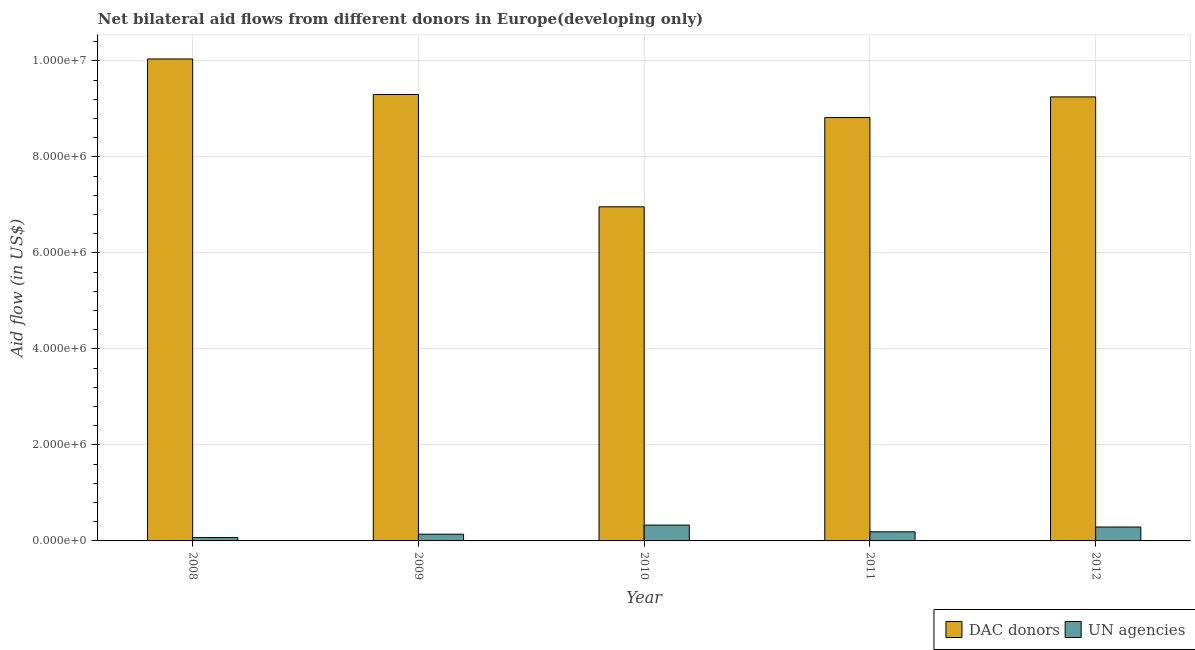Are the number of bars per tick equal to the number of legend labels?
Offer a very short reply. Yes. What is the aid flow from un agencies in 2012?
Ensure brevity in your answer.  2.90e+05. Across all years, what is the maximum aid flow from un agencies?
Make the answer very short. 3.30e+05. Across all years, what is the minimum aid flow from un agencies?
Give a very brief answer. 7.00e+04. In which year was the aid flow from dac donors maximum?
Keep it short and to the point. 2008. In which year was the aid flow from un agencies minimum?
Offer a terse response. 2008. What is the total aid flow from un agencies in the graph?
Your response must be concise. 1.02e+06. What is the difference between the aid flow from un agencies in 2008 and that in 2010?
Your answer should be very brief. -2.60e+05. What is the difference between the aid flow from un agencies in 2010 and the aid flow from dac donors in 2009?
Provide a short and direct response. 1.90e+05. What is the average aid flow from dac donors per year?
Offer a very short reply. 8.87e+06. In the year 2008, what is the difference between the aid flow from un agencies and aid flow from dac donors?
Give a very brief answer. 0. What is the ratio of the aid flow from dac donors in 2010 to that in 2011?
Give a very brief answer. 0.79. What is the difference between the highest and the second highest aid flow from dac donors?
Offer a terse response. 7.40e+05. What is the difference between the highest and the lowest aid flow from dac donors?
Keep it short and to the point. 3.08e+06. In how many years, is the aid flow from un agencies greater than the average aid flow from un agencies taken over all years?
Your answer should be compact. 2. What does the 1st bar from the left in 2011 represents?
Make the answer very short. DAC donors. What does the 1st bar from the right in 2009 represents?
Offer a very short reply. UN agencies. How many years are there in the graph?
Your response must be concise. 5. Are the values on the major ticks of Y-axis written in scientific E-notation?
Keep it short and to the point. Yes. Does the graph contain grids?
Give a very brief answer. Yes. Where does the legend appear in the graph?
Provide a short and direct response. Bottom right. How many legend labels are there?
Keep it short and to the point. 2. How are the legend labels stacked?
Ensure brevity in your answer.  Horizontal. What is the title of the graph?
Offer a terse response. Net bilateral aid flows from different donors in Europe(developing only). What is the label or title of the X-axis?
Your answer should be very brief. Year. What is the label or title of the Y-axis?
Your answer should be very brief. Aid flow (in US$). What is the Aid flow (in US$) of DAC donors in 2008?
Give a very brief answer. 1.00e+07. What is the Aid flow (in US$) of UN agencies in 2008?
Make the answer very short. 7.00e+04. What is the Aid flow (in US$) in DAC donors in 2009?
Offer a terse response. 9.30e+06. What is the Aid flow (in US$) in DAC donors in 2010?
Your response must be concise. 6.96e+06. What is the Aid flow (in US$) in DAC donors in 2011?
Make the answer very short. 8.82e+06. What is the Aid flow (in US$) of DAC donors in 2012?
Offer a terse response. 9.25e+06. Across all years, what is the maximum Aid flow (in US$) of DAC donors?
Your response must be concise. 1.00e+07. Across all years, what is the maximum Aid flow (in US$) of UN agencies?
Your answer should be compact. 3.30e+05. Across all years, what is the minimum Aid flow (in US$) in DAC donors?
Your answer should be compact. 6.96e+06. Across all years, what is the minimum Aid flow (in US$) of UN agencies?
Ensure brevity in your answer.  7.00e+04. What is the total Aid flow (in US$) in DAC donors in the graph?
Provide a succinct answer. 4.44e+07. What is the total Aid flow (in US$) in UN agencies in the graph?
Offer a terse response. 1.02e+06. What is the difference between the Aid flow (in US$) of DAC donors in 2008 and that in 2009?
Give a very brief answer. 7.40e+05. What is the difference between the Aid flow (in US$) in DAC donors in 2008 and that in 2010?
Your answer should be very brief. 3.08e+06. What is the difference between the Aid flow (in US$) in UN agencies in 2008 and that in 2010?
Offer a very short reply. -2.60e+05. What is the difference between the Aid flow (in US$) in DAC donors in 2008 and that in 2011?
Your response must be concise. 1.22e+06. What is the difference between the Aid flow (in US$) in UN agencies in 2008 and that in 2011?
Make the answer very short. -1.20e+05. What is the difference between the Aid flow (in US$) in DAC donors in 2008 and that in 2012?
Make the answer very short. 7.90e+05. What is the difference between the Aid flow (in US$) of DAC donors in 2009 and that in 2010?
Your answer should be compact. 2.34e+06. What is the difference between the Aid flow (in US$) of UN agencies in 2009 and that in 2011?
Make the answer very short. -5.00e+04. What is the difference between the Aid flow (in US$) in UN agencies in 2009 and that in 2012?
Make the answer very short. -1.50e+05. What is the difference between the Aid flow (in US$) in DAC donors in 2010 and that in 2011?
Your answer should be compact. -1.86e+06. What is the difference between the Aid flow (in US$) in DAC donors in 2010 and that in 2012?
Offer a very short reply. -2.29e+06. What is the difference between the Aid flow (in US$) in UN agencies in 2010 and that in 2012?
Provide a short and direct response. 4.00e+04. What is the difference between the Aid flow (in US$) in DAC donors in 2011 and that in 2012?
Provide a short and direct response. -4.30e+05. What is the difference between the Aid flow (in US$) in UN agencies in 2011 and that in 2012?
Ensure brevity in your answer.  -1.00e+05. What is the difference between the Aid flow (in US$) in DAC donors in 2008 and the Aid flow (in US$) in UN agencies in 2009?
Provide a short and direct response. 9.90e+06. What is the difference between the Aid flow (in US$) in DAC donors in 2008 and the Aid flow (in US$) in UN agencies in 2010?
Keep it short and to the point. 9.71e+06. What is the difference between the Aid flow (in US$) in DAC donors in 2008 and the Aid flow (in US$) in UN agencies in 2011?
Provide a succinct answer. 9.85e+06. What is the difference between the Aid flow (in US$) of DAC donors in 2008 and the Aid flow (in US$) of UN agencies in 2012?
Offer a very short reply. 9.75e+06. What is the difference between the Aid flow (in US$) of DAC donors in 2009 and the Aid flow (in US$) of UN agencies in 2010?
Keep it short and to the point. 8.97e+06. What is the difference between the Aid flow (in US$) in DAC donors in 2009 and the Aid flow (in US$) in UN agencies in 2011?
Keep it short and to the point. 9.11e+06. What is the difference between the Aid flow (in US$) in DAC donors in 2009 and the Aid flow (in US$) in UN agencies in 2012?
Your answer should be compact. 9.01e+06. What is the difference between the Aid flow (in US$) in DAC donors in 2010 and the Aid flow (in US$) in UN agencies in 2011?
Your answer should be compact. 6.77e+06. What is the difference between the Aid flow (in US$) of DAC donors in 2010 and the Aid flow (in US$) of UN agencies in 2012?
Offer a terse response. 6.67e+06. What is the difference between the Aid flow (in US$) of DAC donors in 2011 and the Aid flow (in US$) of UN agencies in 2012?
Your answer should be compact. 8.53e+06. What is the average Aid flow (in US$) in DAC donors per year?
Provide a succinct answer. 8.87e+06. What is the average Aid flow (in US$) in UN agencies per year?
Give a very brief answer. 2.04e+05. In the year 2008, what is the difference between the Aid flow (in US$) in DAC donors and Aid flow (in US$) in UN agencies?
Provide a succinct answer. 9.97e+06. In the year 2009, what is the difference between the Aid flow (in US$) in DAC donors and Aid flow (in US$) in UN agencies?
Offer a terse response. 9.16e+06. In the year 2010, what is the difference between the Aid flow (in US$) in DAC donors and Aid flow (in US$) in UN agencies?
Offer a very short reply. 6.63e+06. In the year 2011, what is the difference between the Aid flow (in US$) of DAC donors and Aid flow (in US$) of UN agencies?
Provide a succinct answer. 8.63e+06. In the year 2012, what is the difference between the Aid flow (in US$) of DAC donors and Aid flow (in US$) of UN agencies?
Provide a succinct answer. 8.96e+06. What is the ratio of the Aid flow (in US$) in DAC donors in 2008 to that in 2009?
Provide a short and direct response. 1.08. What is the ratio of the Aid flow (in US$) in DAC donors in 2008 to that in 2010?
Offer a terse response. 1.44. What is the ratio of the Aid flow (in US$) in UN agencies in 2008 to that in 2010?
Offer a terse response. 0.21. What is the ratio of the Aid flow (in US$) in DAC donors in 2008 to that in 2011?
Keep it short and to the point. 1.14. What is the ratio of the Aid flow (in US$) in UN agencies in 2008 to that in 2011?
Make the answer very short. 0.37. What is the ratio of the Aid flow (in US$) in DAC donors in 2008 to that in 2012?
Provide a short and direct response. 1.09. What is the ratio of the Aid flow (in US$) of UN agencies in 2008 to that in 2012?
Provide a succinct answer. 0.24. What is the ratio of the Aid flow (in US$) of DAC donors in 2009 to that in 2010?
Your answer should be compact. 1.34. What is the ratio of the Aid flow (in US$) of UN agencies in 2009 to that in 2010?
Make the answer very short. 0.42. What is the ratio of the Aid flow (in US$) of DAC donors in 2009 to that in 2011?
Make the answer very short. 1.05. What is the ratio of the Aid flow (in US$) of UN agencies in 2009 to that in 2011?
Your response must be concise. 0.74. What is the ratio of the Aid flow (in US$) of DAC donors in 2009 to that in 2012?
Offer a very short reply. 1.01. What is the ratio of the Aid flow (in US$) of UN agencies in 2009 to that in 2012?
Your response must be concise. 0.48. What is the ratio of the Aid flow (in US$) of DAC donors in 2010 to that in 2011?
Give a very brief answer. 0.79. What is the ratio of the Aid flow (in US$) of UN agencies in 2010 to that in 2011?
Keep it short and to the point. 1.74. What is the ratio of the Aid flow (in US$) of DAC donors in 2010 to that in 2012?
Your answer should be very brief. 0.75. What is the ratio of the Aid flow (in US$) of UN agencies in 2010 to that in 2012?
Offer a very short reply. 1.14. What is the ratio of the Aid flow (in US$) in DAC donors in 2011 to that in 2012?
Make the answer very short. 0.95. What is the ratio of the Aid flow (in US$) in UN agencies in 2011 to that in 2012?
Provide a succinct answer. 0.66. What is the difference between the highest and the second highest Aid flow (in US$) of DAC donors?
Provide a succinct answer. 7.40e+05. What is the difference between the highest and the lowest Aid flow (in US$) of DAC donors?
Your answer should be very brief. 3.08e+06. What is the difference between the highest and the lowest Aid flow (in US$) of UN agencies?
Offer a very short reply. 2.60e+05. 